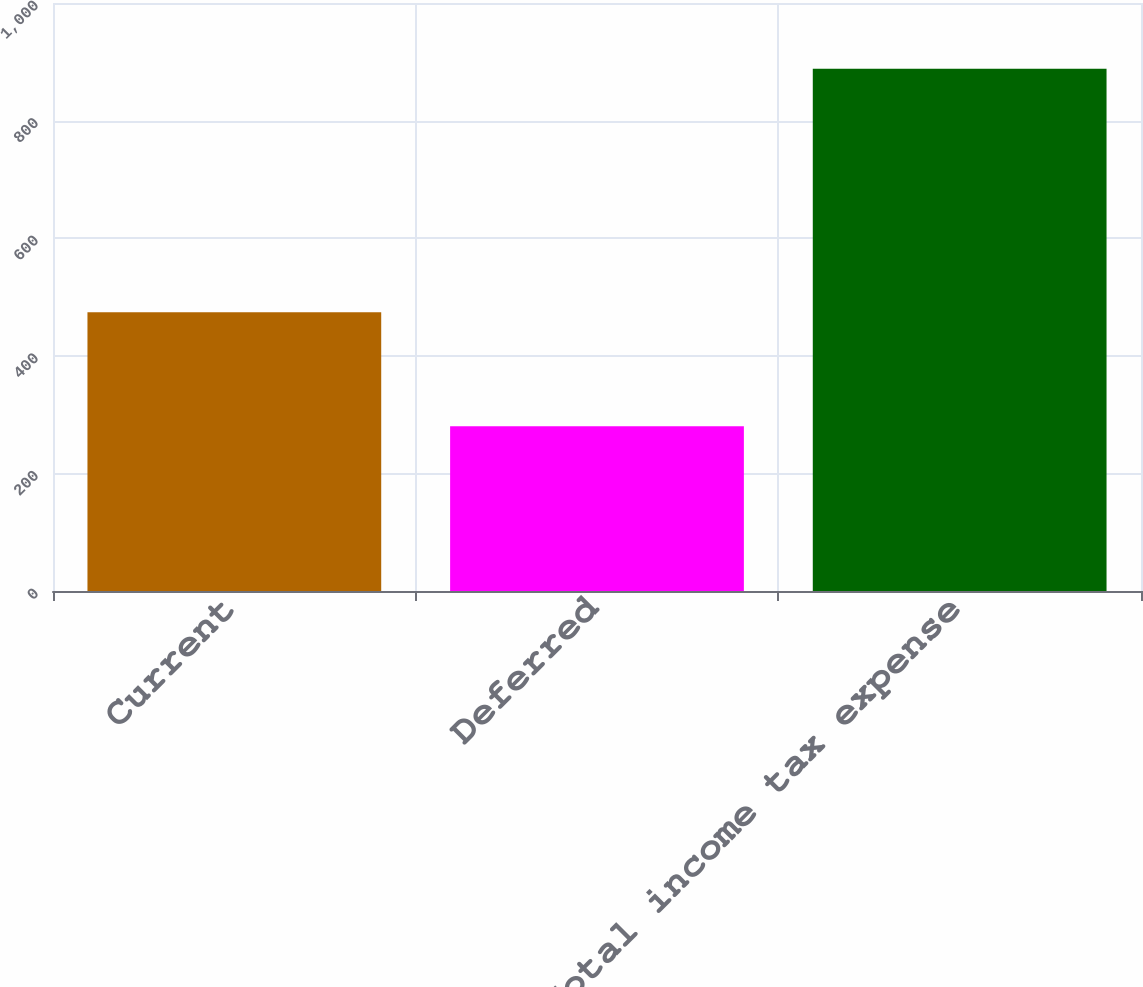<chart> <loc_0><loc_0><loc_500><loc_500><bar_chart><fcel>Current<fcel>Deferred<fcel>Total income tax expense<nl><fcel>474<fcel>280<fcel>888<nl></chart> 